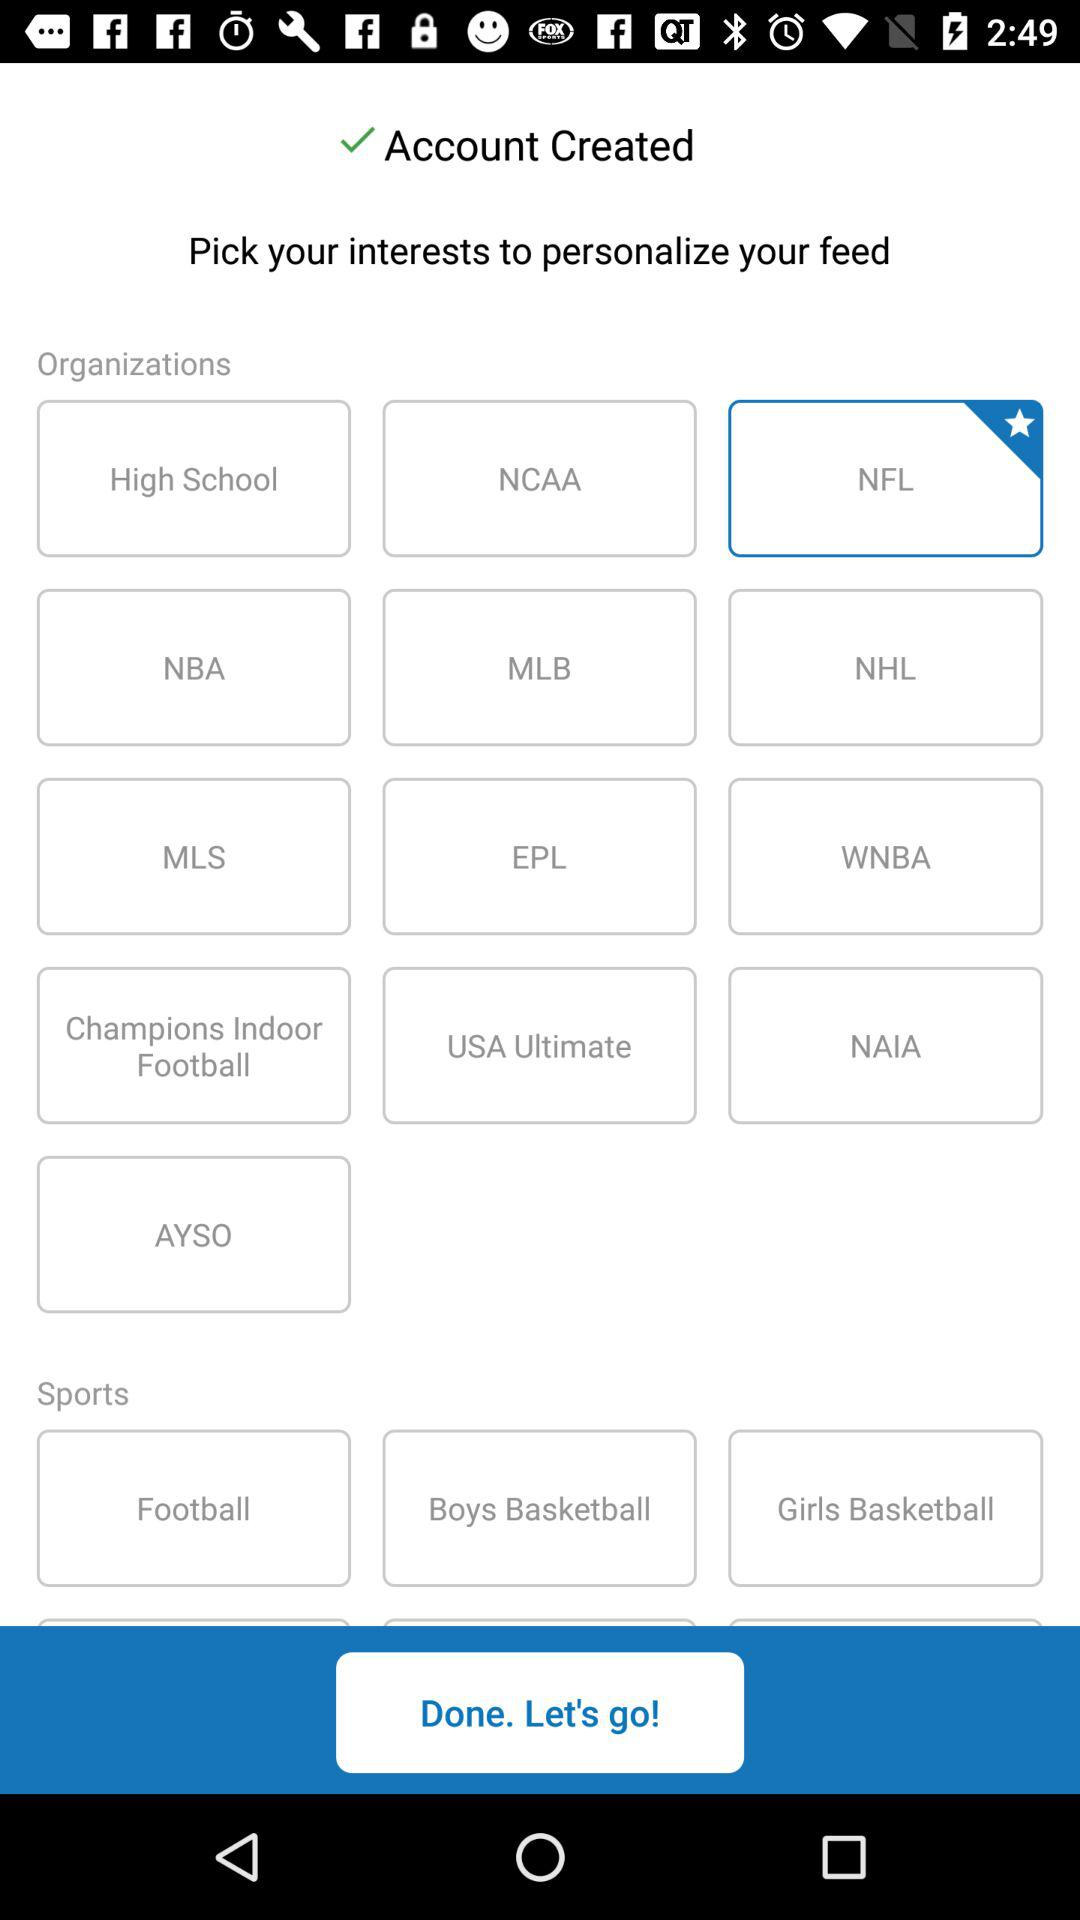What is the selected option? The selected option is "NFL". 